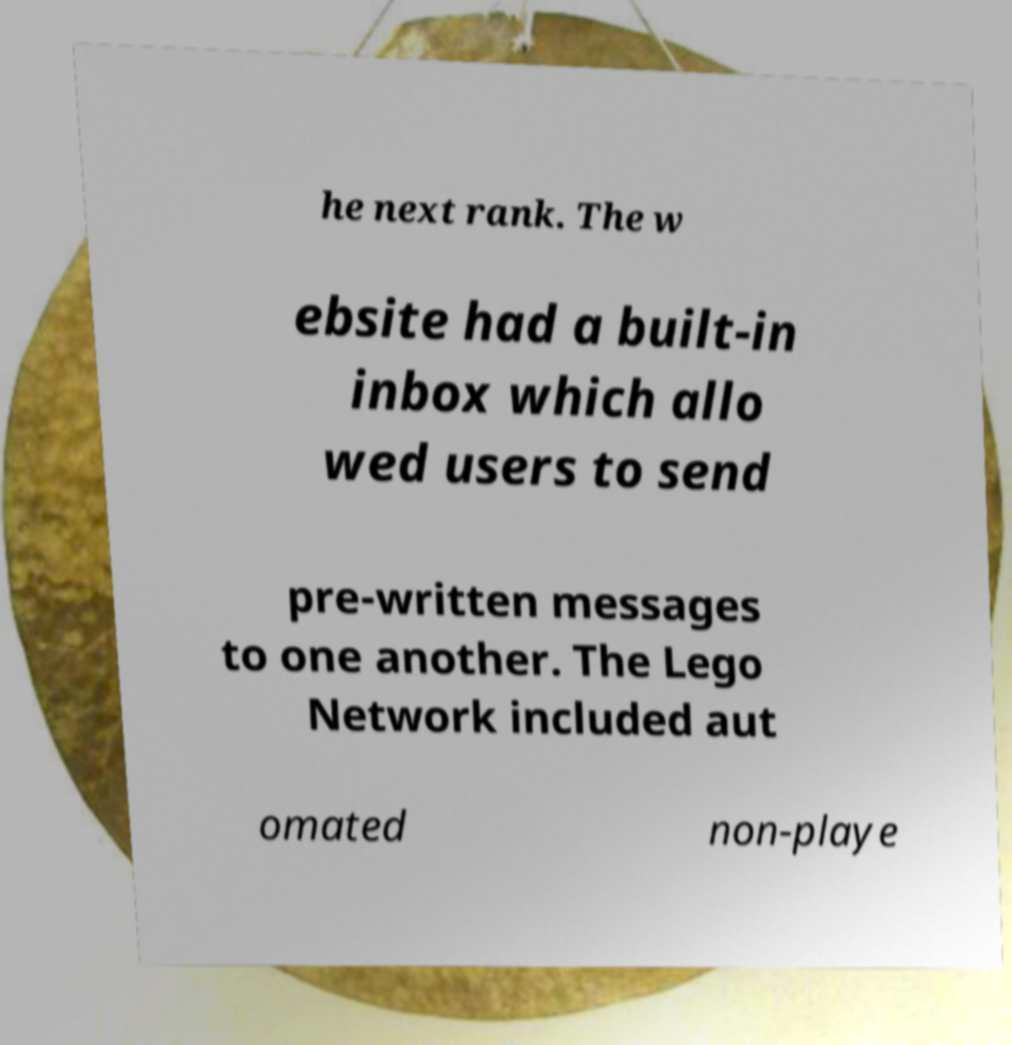Please read and relay the text visible in this image. What does it say? he next rank. The w ebsite had a built-in inbox which allo wed users to send pre-written messages to one another. The Lego Network included aut omated non-playe 